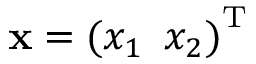<formula> <loc_0><loc_0><loc_500><loc_500>{ x } = { ( x _ { 1 } \, x _ { 2 } ) } ^ { T }</formula> 